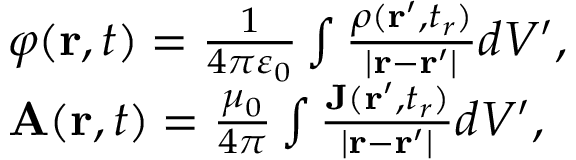<formula> <loc_0><loc_0><loc_500><loc_500>{ \begin{array} { r l } & { \varphi ( r , t ) = { \frac { 1 } { 4 \pi \varepsilon _ { 0 } } } \int { \frac { \rho ( r ^ { \prime } , t _ { r } ) } { | r - r ^ { \prime } | } } d V ^ { \prime } , } \\ & { A ( r , t ) = { \frac { \mu _ { 0 } } { 4 \pi } } \int { \frac { J ( r ^ { \prime } , t _ { r } ) } { | r - r ^ { \prime } | } } d V ^ { \prime } , } \end{array} }</formula> 